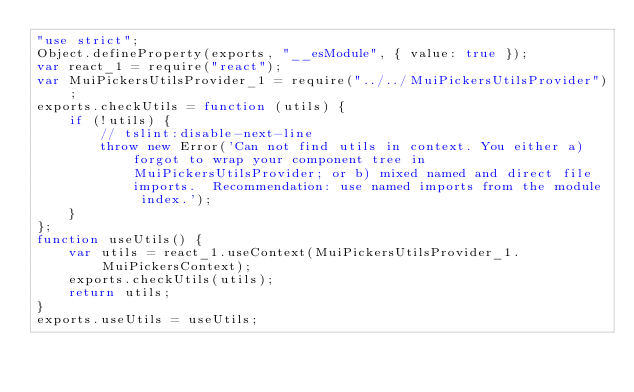Convert code to text. <code><loc_0><loc_0><loc_500><loc_500><_JavaScript_>"use strict";
Object.defineProperty(exports, "__esModule", { value: true });
var react_1 = require("react");
var MuiPickersUtilsProvider_1 = require("../../MuiPickersUtilsProvider");
exports.checkUtils = function (utils) {
    if (!utils) {
        // tslint:disable-next-line
        throw new Error('Can not find utils in context. You either a) forgot to wrap your component tree in MuiPickersUtilsProvider; or b) mixed named and direct file imports.  Recommendation: use named imports from the module index.');
    }
};
function useUtils() {
    var utils = react_1.useContext(MuiPickersUtilsProvider_1.MuiPickersContext);
    exports.checkUtils(utils);
    return utils;
}
exports.useUtils = useUtils;
</code> 